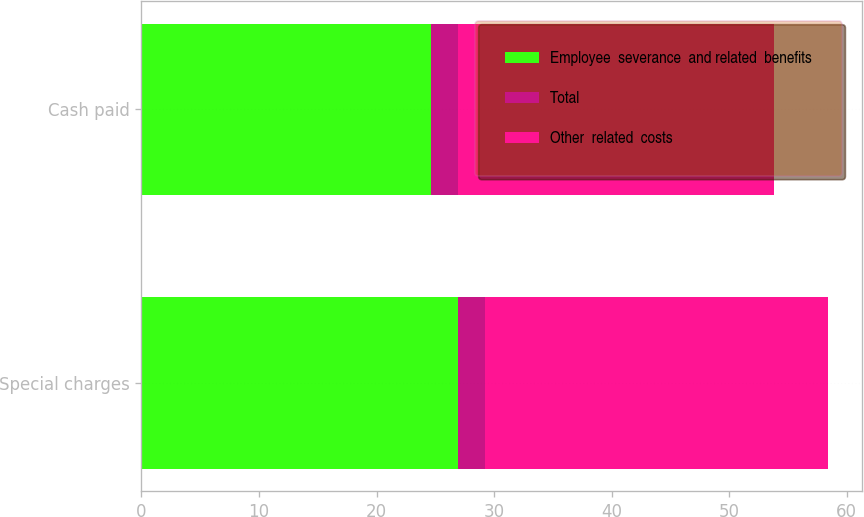Convert chart. <chart><loc_0><loc_0><loc_500><loc_500><stacked_bar_chart><ecel><fcel>Special charges<fcel>Cash paid<nl><fcel>Employee  severance  and related  benefits<fcel>26.9<fcel>24.6<nl><fcel>Total<fcel>2.3<fcel>2.3<nl><fcel>Other  related  costs<fcel>29.2<fcel>26.9<nl></chart> 